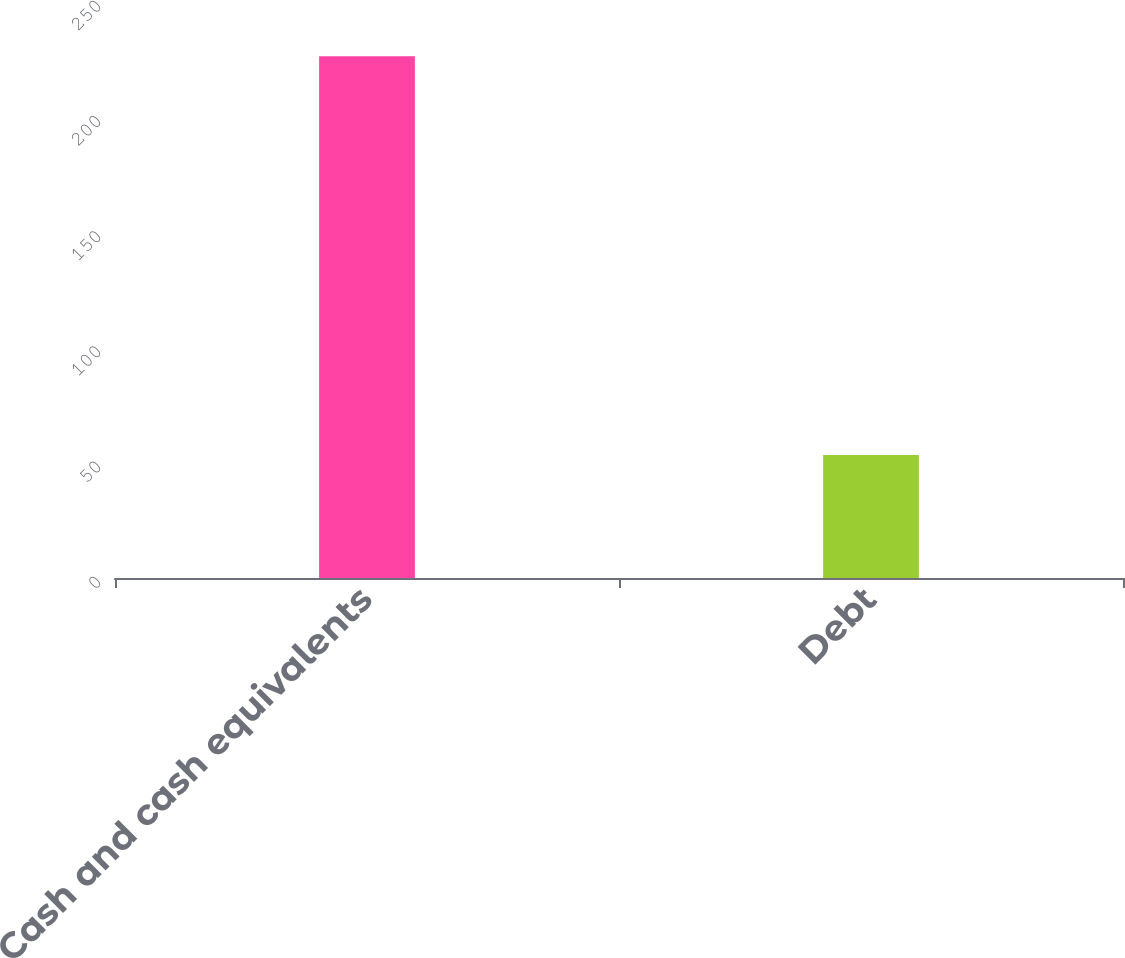Convert chart to OTSL. <chart><loc_0><loc_0><loc_500><loc_500><bar_chart><fcel>Cash and cash equivalents<fcel>Debt<nl><fcel>226.4<fcel>53.4<nl></chart> 